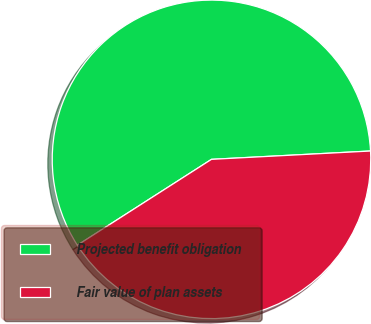<chart> <loc_0><loc_0><loc_500><loc_500><pie_chart><fcel>Projected benefit obligation<fcel>Fair value of plan assets<nl><fcel>58.23%<fcel>41.77%<nl></chart> 